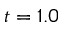Convert formula to latex. <formula><loc_0><loc_0><loc_500><loc_500>t = 1 . 0</formula> 